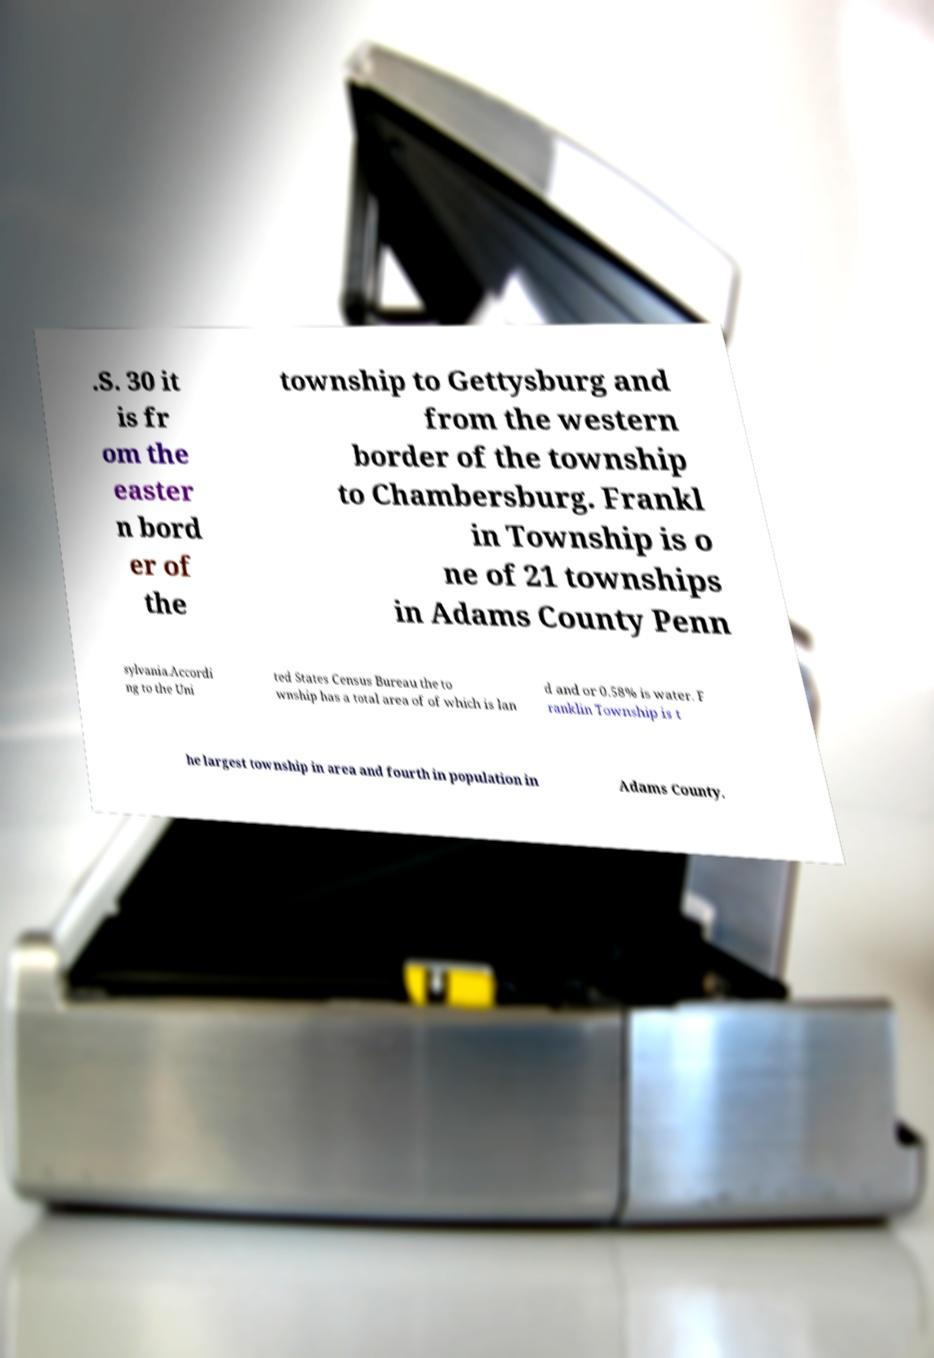There's text embedded in this image that I need extracted. Can you transcribe it verbatim? .S. 30 it is fr om the easter n bord er of the township to Gettysburg and from the western border of the township to Chambersburg. Frankl in Township is o ne of 21 townships in Adams County Penn sylvania.Accordi ng to the Uni ted States Census Bureau the to wnship has a total area of of which is lan d and or 0.58% is water. F ranklin Township is t he largest township in area and fourth in population in Adams County. 